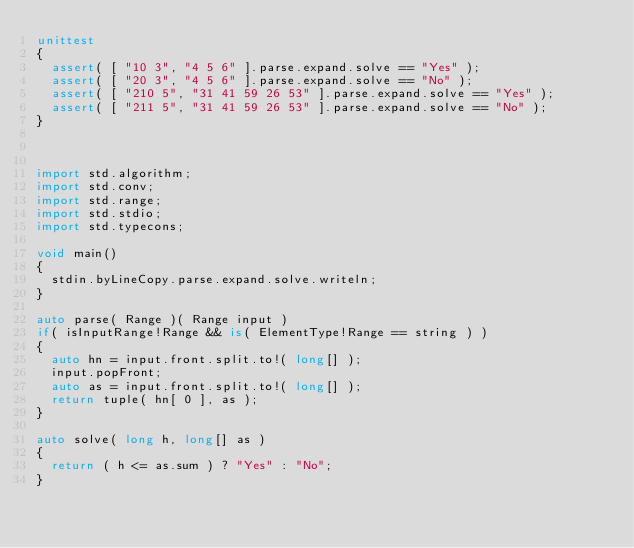Convert code to text. <code><loc_0><loc_0><loc_500><loc_500><_D_>unittest
{
	assert( [ "10 3", "4 5 6" ].parse.expand.solve == "Yes" );
	assert( [ "20 3", "4 5 6" ].parse.expand.solve == "No" );
	assert( [ "210 5", "31 41 59 26 53" ].parse.expand.solve == "Yes" );
	assert( [ "211 5", "31 41 59 26 53" ].parse.expand.solve == "No" );
}



import std.algorithm;
import std.conv;
import std.range;
import std.stdio;
import std.typecons;

void main()
{
	stdin.byLineCopy.parse.expand.solve.writeln;
}

auto parse( Range )( Range input )
if( isInputRange!Range && is( ElementType!Range == string ) )
{
	auto hn = input.front.split.to!( long[] );
	input.popFront;
	auto as = input.front.split.to!( long[] );
	return tuple( hn[ 0 ], as );
}

auto solve( long h, long[] as )
{
	return ( h <= as.sum ) ? "Yes" : "No";
}
</code> 